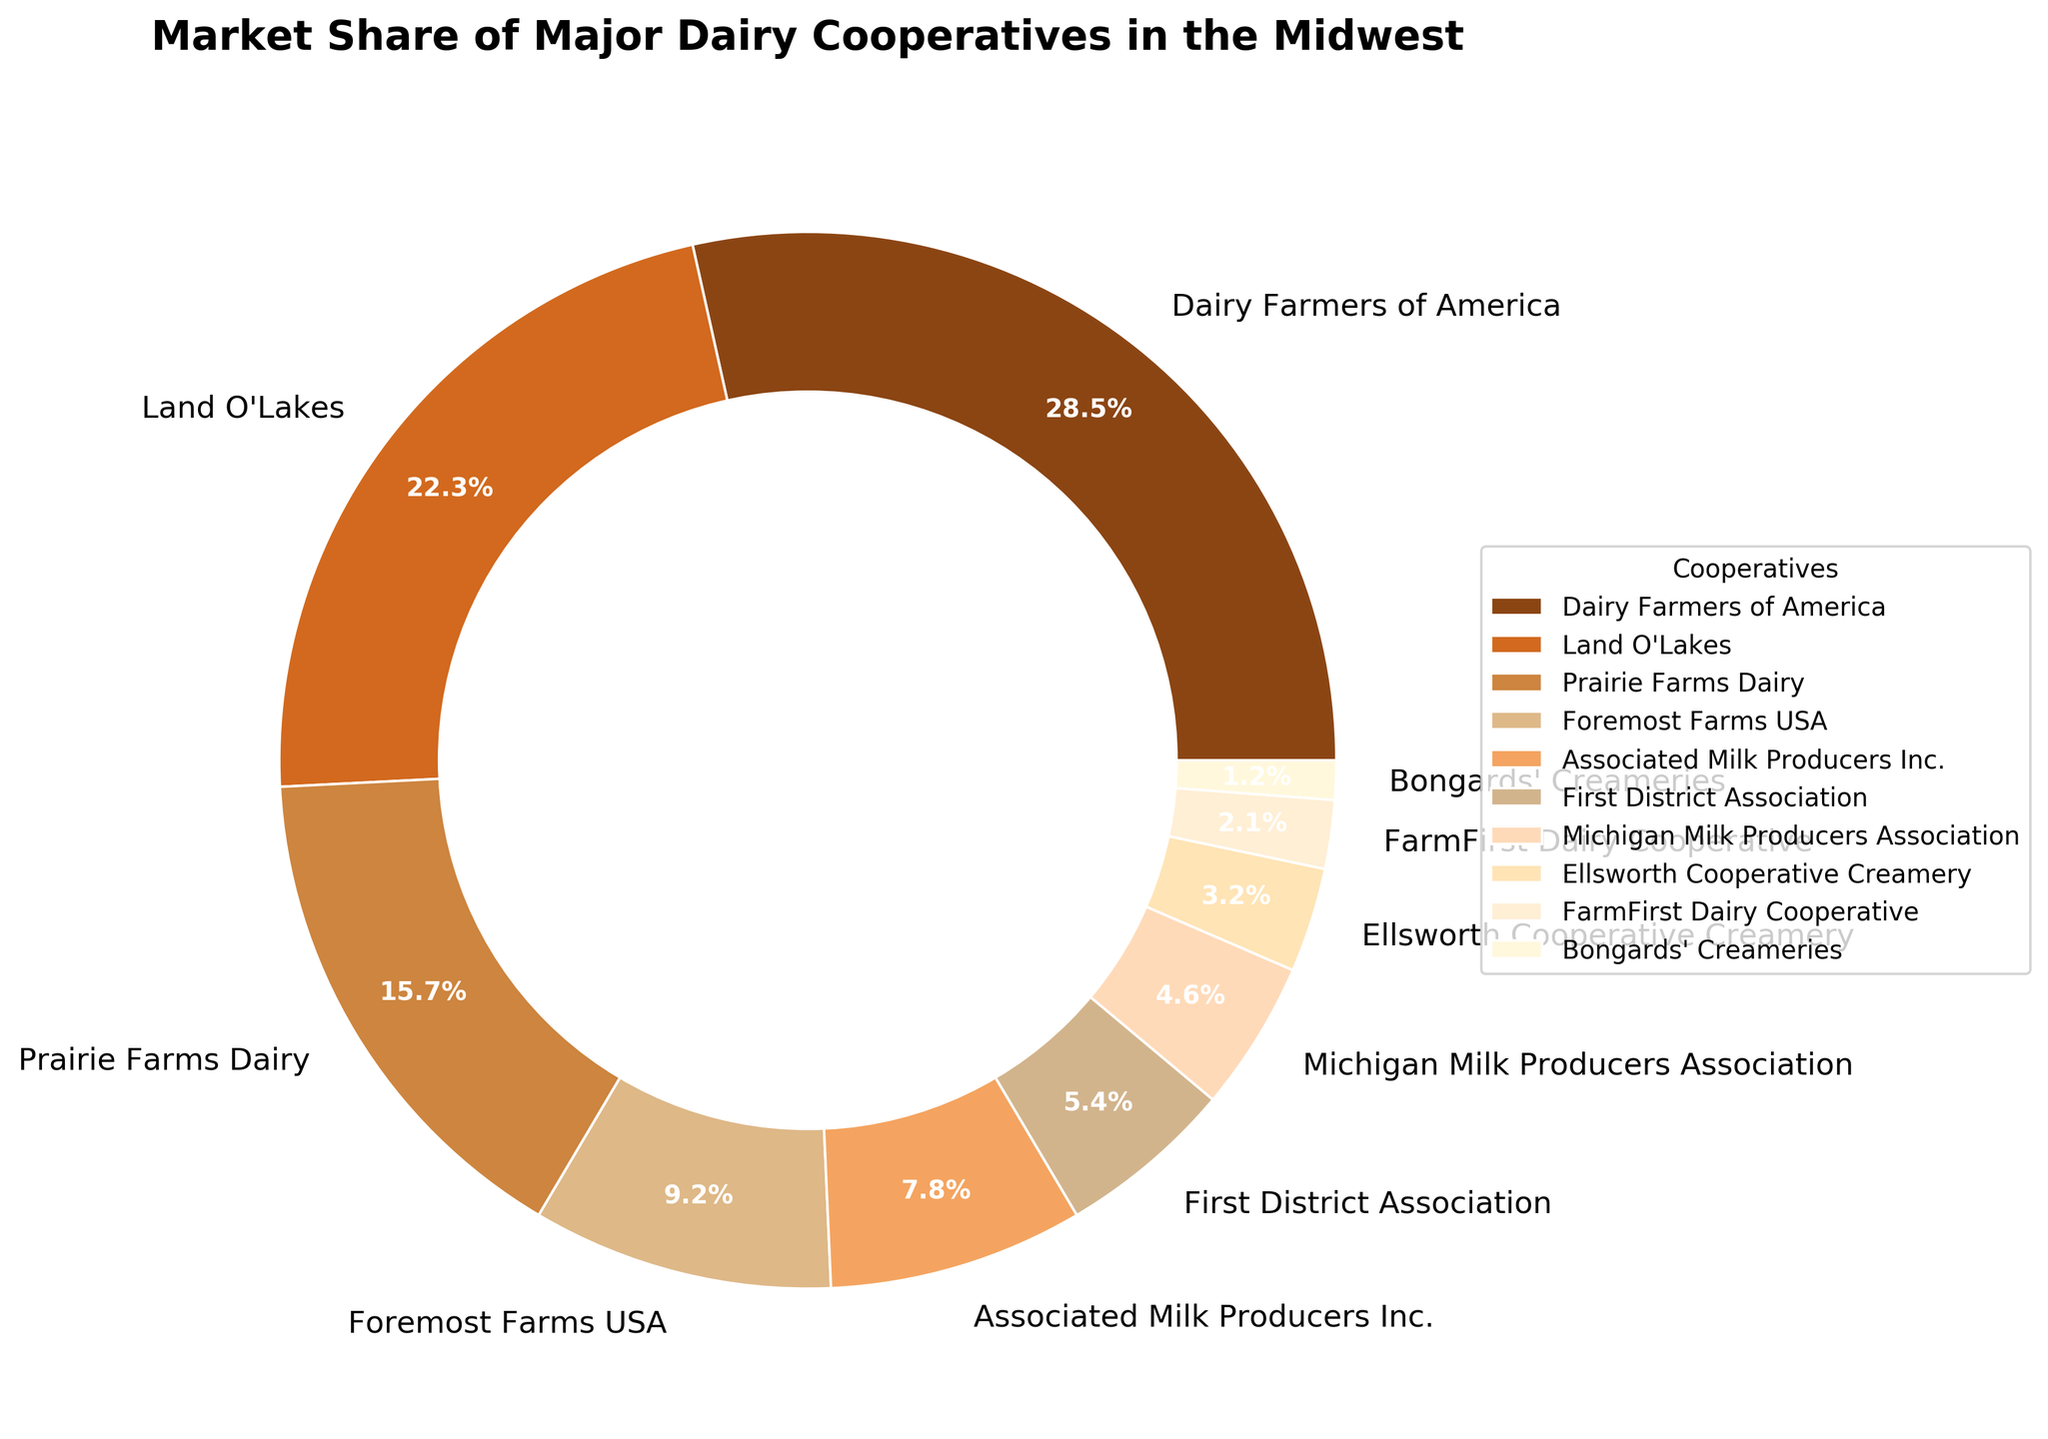Which dairy cooperative has the largest market share? By looking at the pie chart, we can see which section occupies the largest portion of the chart. "Dairy Farmers of America" has the largest section.
Answer: Dairy Farmers of America Which two cooperatives together have a market share greater than 35%? By observing the sizes of the pie sections and their labels, we can see that "Dairy Farmers of America" and "Land O'Lakes" together have market shares of 28.5% and 22.3%, respectively. Adding these together gives 50.8%, which is greater than 35%.
Answer: Dairy Farmers of America and Land O'Lakes What is the combined market share of the three smallest cooperatives shown? The three smallest cooperatives on the pie chart are "Bongards' Creameries" (1.2%), "FarmFirst Dairy Cooperative" (2.1%), and "Ellsworth Cooperative Creamery" (3.2%). Adding these percentages together gives 6.5%.
Answer: 6.5% How does the market share of Prairie Farms Dairy compare to that of Foremost Farms USA? By comparing the sizes of the sections in the pie chart, Prairie Farms Dairy has a market share of 15.7%, while Foremost Farms USA has a market share of 9.2%. Prairie Farms Dairy has a larger market share.
Answer: Prairie Farms Dairy is larger Which cooperative has the closest market share to 5%? By looking at the pie chart, "First District Association" has a market share of 5.4%, which is the closest to 5%.
Answer: First District Association If the market share of Associated Milk Producers Inc. increased by 3%, what would their new market share be? The original market share of Associated Milk Producers Inc. is 7.8%. If it increased by 3%, the new market share would be 7.8% + 3% = 10.8%.
Answer: 10.8% Which cooperative has a market share almost double that of Michigan Milk Producers Association? Michigan Milk Producers Association has a market share of 4.6%. By inspecting the pie chart, "First District Association" with a 5.4% market share is closest to being almost double (4.6 * 2 = 9.2 which is closest to 9.2% of Foremost Farms USA, but it's less than half).
Answer: Foremost Farms USA What is the difference in market share between Land O'Lakes and Michigan Milk Producers Association? Land O'Lakes has a market share of 22.3%, and Michigan Milk Producers Association has a market share of 4.6%. The difference is 22.3% - 4.6% = 17.7%.
Answer: 17.7% What fraction of the total market share is held by Dairy Farmers of America? Dairy Farmers of America has a market share of 28.5%. To find the fraction of the total, we consider the total market share is 100%. Thus, the fraction is 28.5/100, which simplifies to 285/1000 or approximately 29/100.
Answer: 29/100 